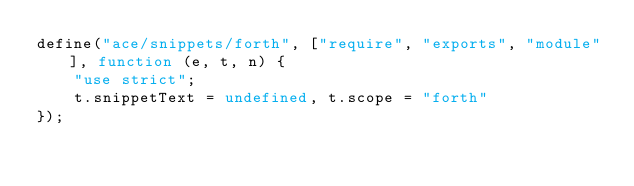Convert code to text. <code><loc_0><loc_0><loc_500><loc_500><_JavaScript_>define("ace/snippets/forth", ["require", "exports", "module"], function (e, t, n) {
	"use strict";
	t.snippetText = undefined, t.scope = "forth"
});</code> 